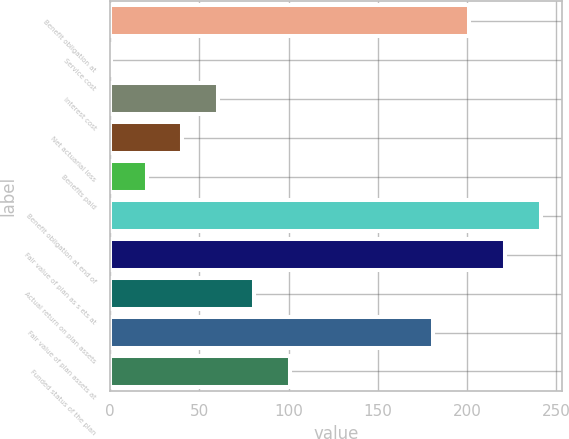Convert chart to OTSL. <chart><loc_0><loc_0><loc_500><loc_500><bar_chart><fcel>Benefit obligation at<fcel>Service cost<fcel>Interest cost<fcel>Net actuarial loss<fcel>Benefits paid<fcel>Benefit obligation at end of<fcel>Fair value of plan as s ets at<fcel>Actual return on plan assets<fcel>Fair value of plan assets at<fcel>Funded status of the plan<nl><fcel>201.1<fcel>0.4<fcel>60.61<fcel>40.54<fcel>20.47<fcel>241.24<fcel>221.17<fcel>80.68<fcel>181.03<fcel>100.75<nl></chart> 